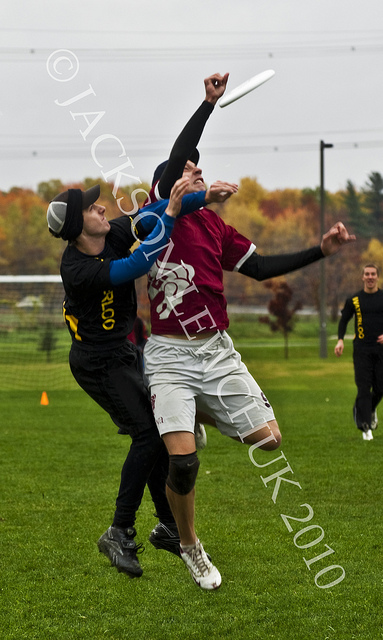What might stop you from using this image in a commercial capacity?
A. disturbing nature
B. sexual nature
C. watermark
D. offensive nature
Answer with the option's letter from the given choices directly. C 